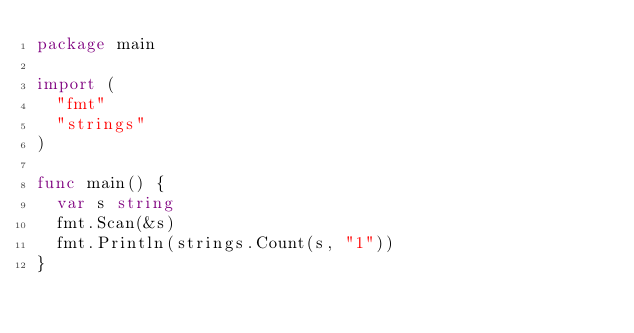Convert code to text. <code><loc_0><loc_0><loc_500><loc_500><_Go_>package main

import (
  "fmt"
  "strings"
)

func main() {
  var s string
  fmt.Scan(&s)
  fmt.Println(strings.Count(s, "1"))
}
  </code> 